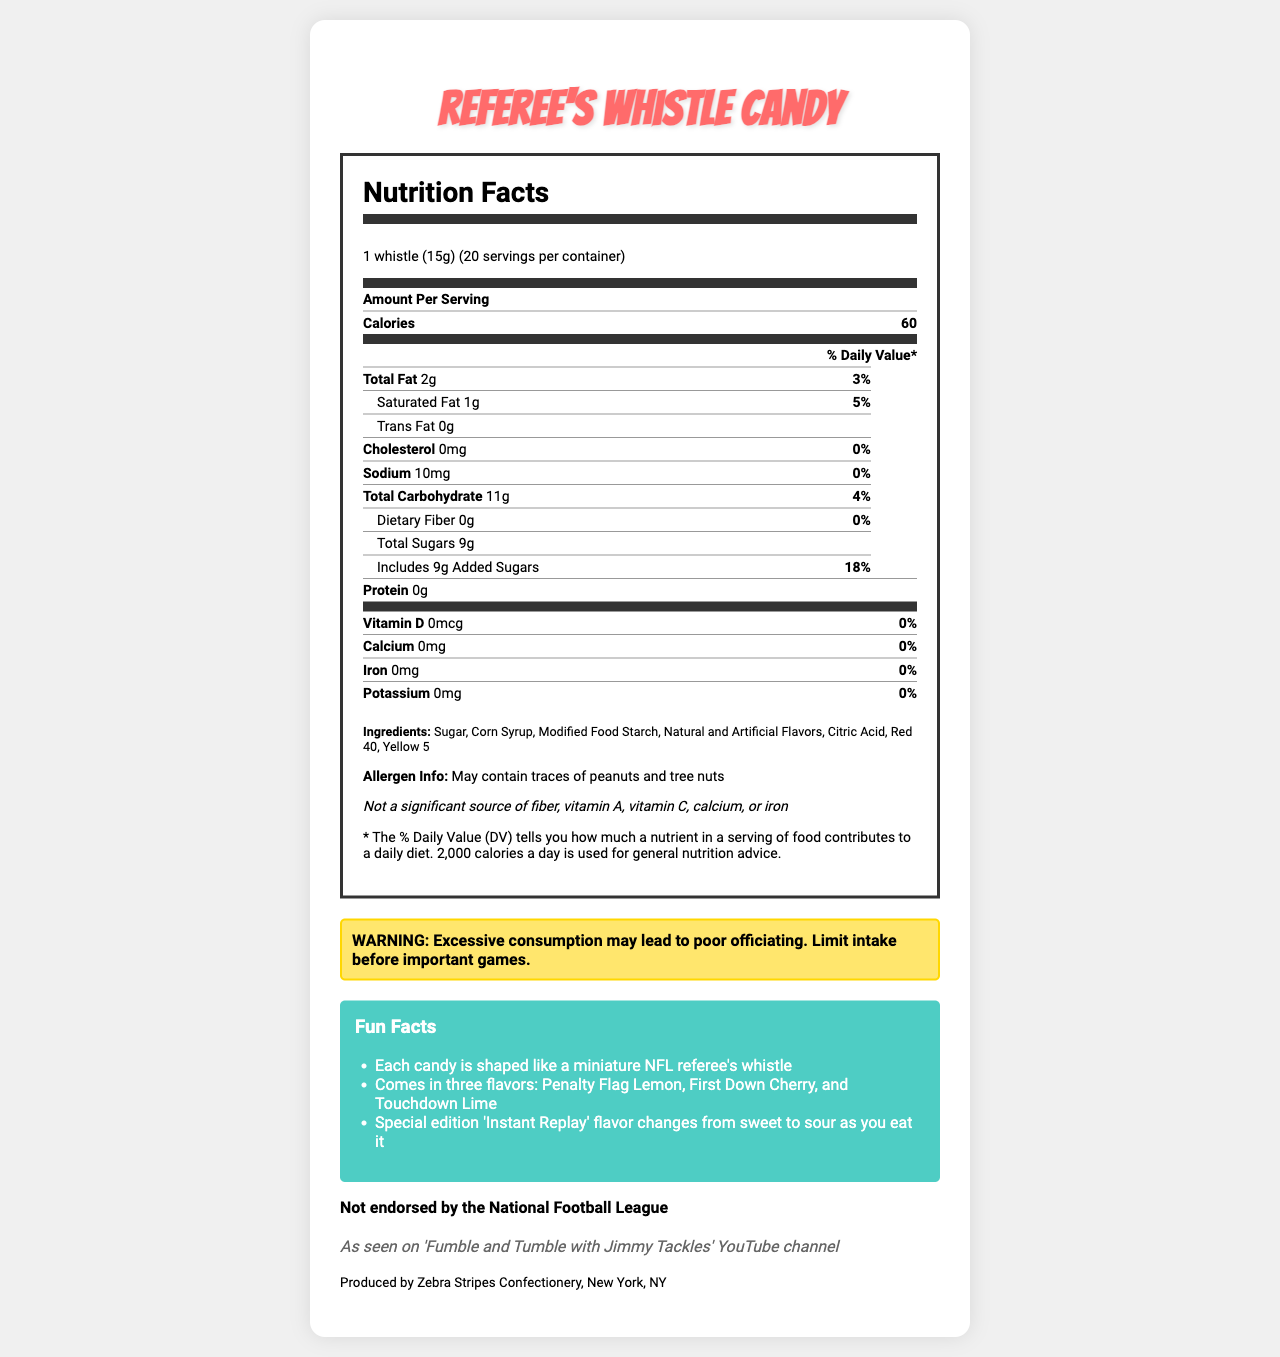what is the serving size for Referee's Whistle Candy? The serving size is clearly stated at the top of the Nutrition Facts section.
Answer: 1 whistle (15g) how many calories are in one serving of Referee's Whistle Candy? The number of calories per serving is listed under the "Amount Per Serving" section.
Answer: 60 calories what is the total fat content per serving? The total fat content per serving is listed under the "Total Fat" section in the Nutrition Facts.
Answer: 2g which company produces Referee's Whistle Candy? The manufacturer's information states that the product is produced by Zebra Stripes Confectionery.
Answer: Zebra Stripes Confectionery what flavors does Referee's Whistle Candy come in? The Fun Facts section lists the available flavors.
Answer: Penalty Flag Lemon, First Down Cherry, Touchdown Lime, and Instant Replay how much saturated fat is in one serving? The saturated fat content is listed as 1g in the Nutrition Facts table.
Answer: 1g what is the serving size and servings per container for this candy? The serving size and servings per container are stated at the top of the Nutrition Facts label.
Answer: 1 whistle (15g), 20 servings per container what is the warning statement provided on the label? The warning statement is highlighted in a special section below the Nutrition Facts.
Answer: WARNING: Excessive consumption may lead to poor officiating. Limit intake before important games. which of the following nutrients are not present in Referee's Whistle Candy? A. Calcium B. Vitamin D C. Iron D. All of the above The label lists Vitamin D, Calcium, and Iron as 0% Daily Value, indicating they are not present.
Answer: D. All of the above how much added sugar is in one serving? The amount of added sugars per serving is clearly listed in the indent under "Total Sugars."
Answer: 9g is Referee's Whistle Candy endorsed by the NFL? The document explicitly states "Not endorsed by the National Football League."
Answer: No can the allergen information on the label confirm if the product contains peanuts? The allergen info states "May contain traces of peanuts and tree nuts," which does not confirm the presence of peanuts.
Answer: No summarize the main points of the Referee's Whistle Candy Nutrition Facts document. The summary should highlight the key nutritional details, warning statement, fun facts, and endorsement status.
Answer: The document provides detailed nutritional information for Referee's Whistle Candy, which includes serving size, calories, and nutrient contents per serving. It lists ingredients, allergen info, and includes a warning about excessive consumption leading to poor officiating. Fun facts about flavors and shapes are included, and it is noted that the product is not NFL-endorsed. how much sodium is in a serving? The sodium content per serving is clearly listed in the Nutrition Facts as 10mg.
Answer: 10mg 